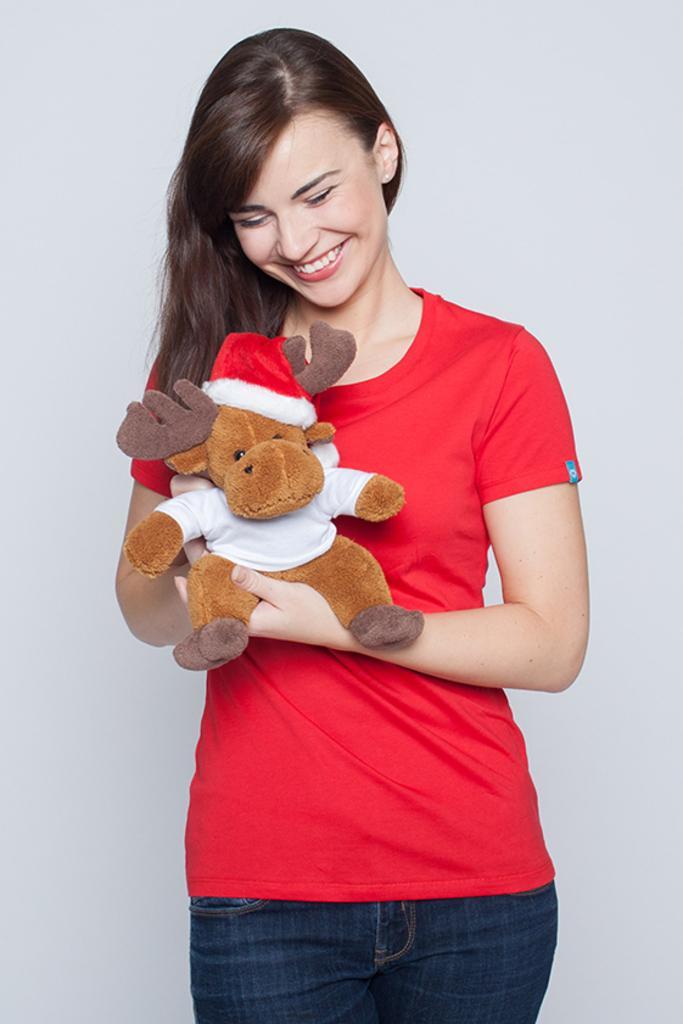Please provide a concise description of this image. In this image I can see a woman standing and smiling. She is wearing a red t shirt and holding a soft toy. There is a wall at the back. 